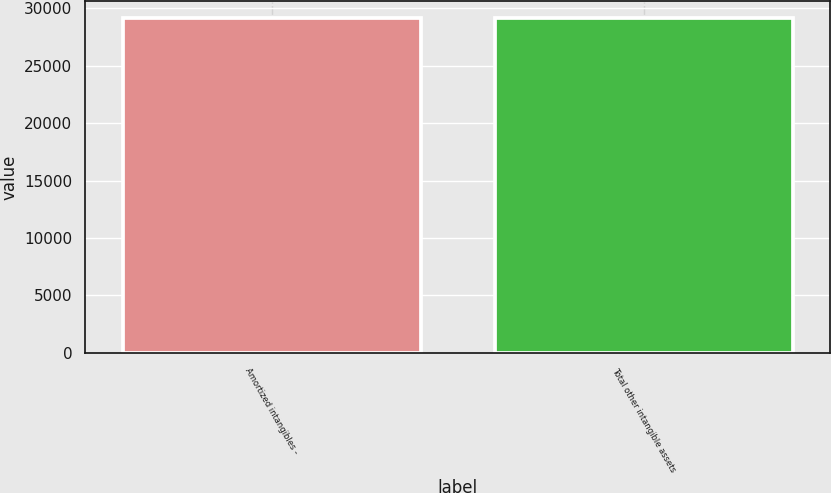Convert chart. <chart><loc_0><loc_0><loc_500><loc_500><bar_chart><fcel>Amortized intangibles -<fcel>Total other intangible assets<nl><fcel>29188<fcel>29188.1<nl></chart> 